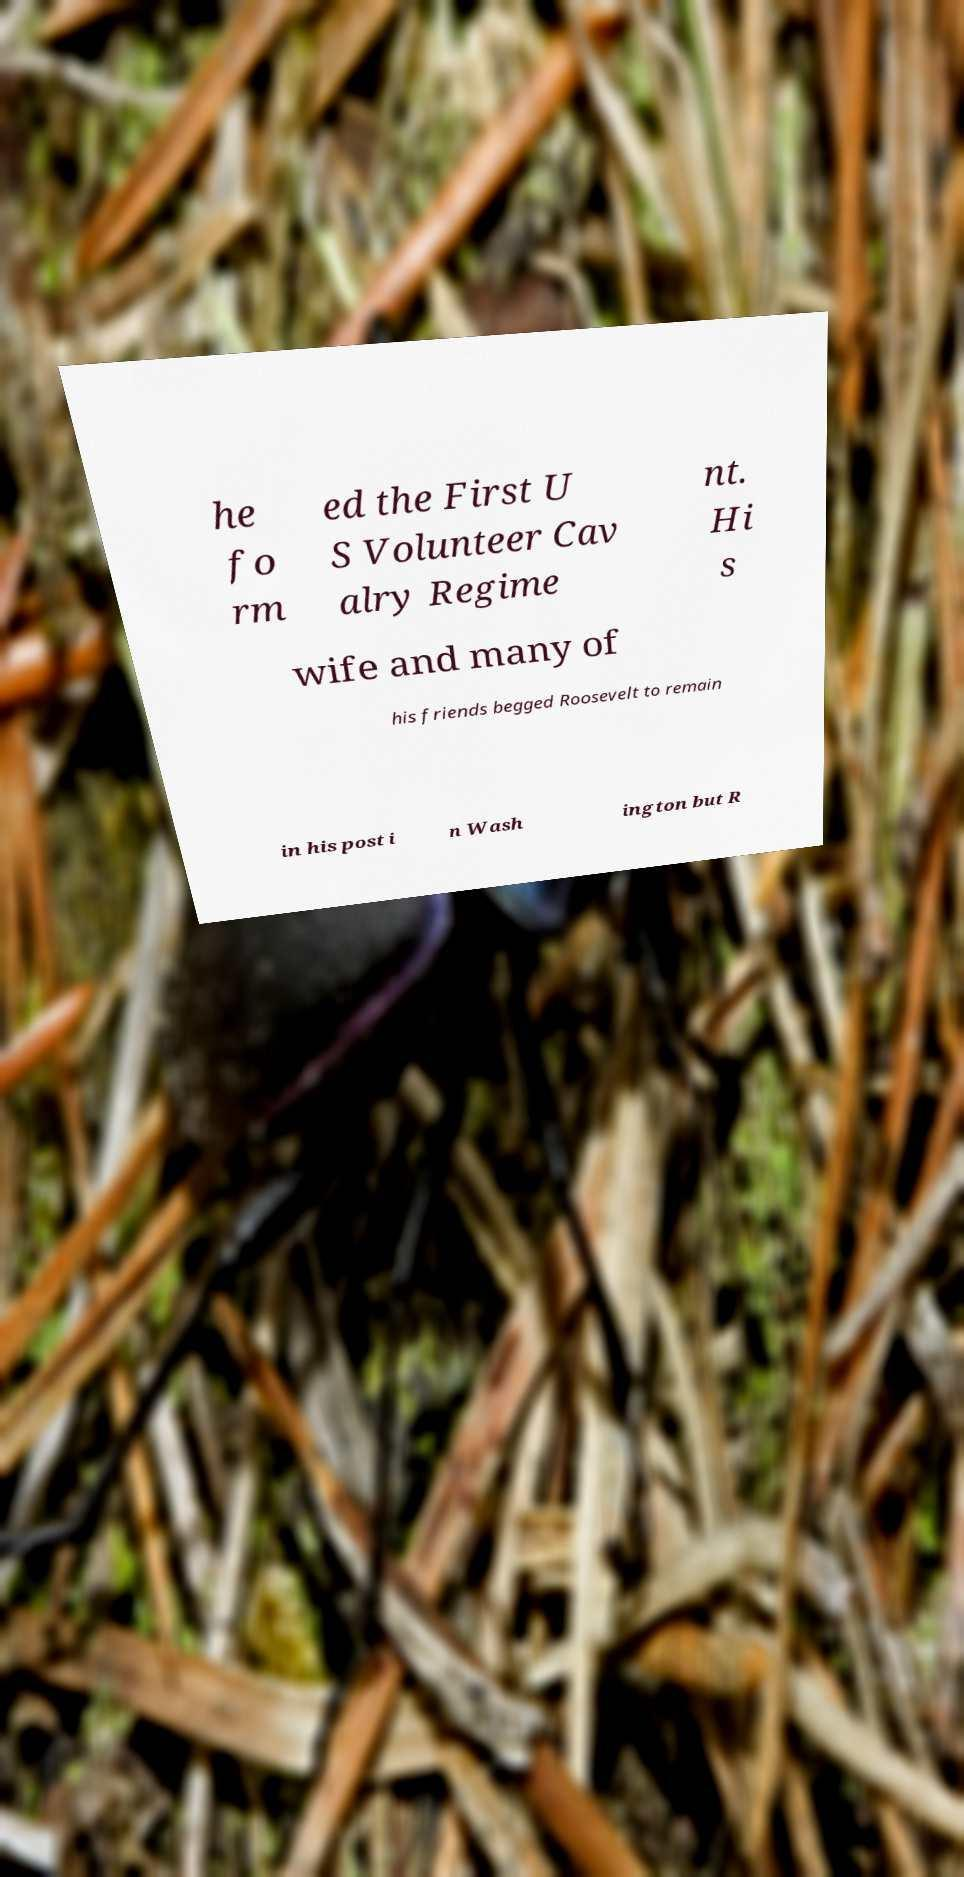I need the written content from this picture converted into text. Can you do that? he fo rm ed the First U S Volunteer Cav alry Regime nt. Hi s wife and many of his friends begged Roosevelt to remain in his post i n Wash ington but R 